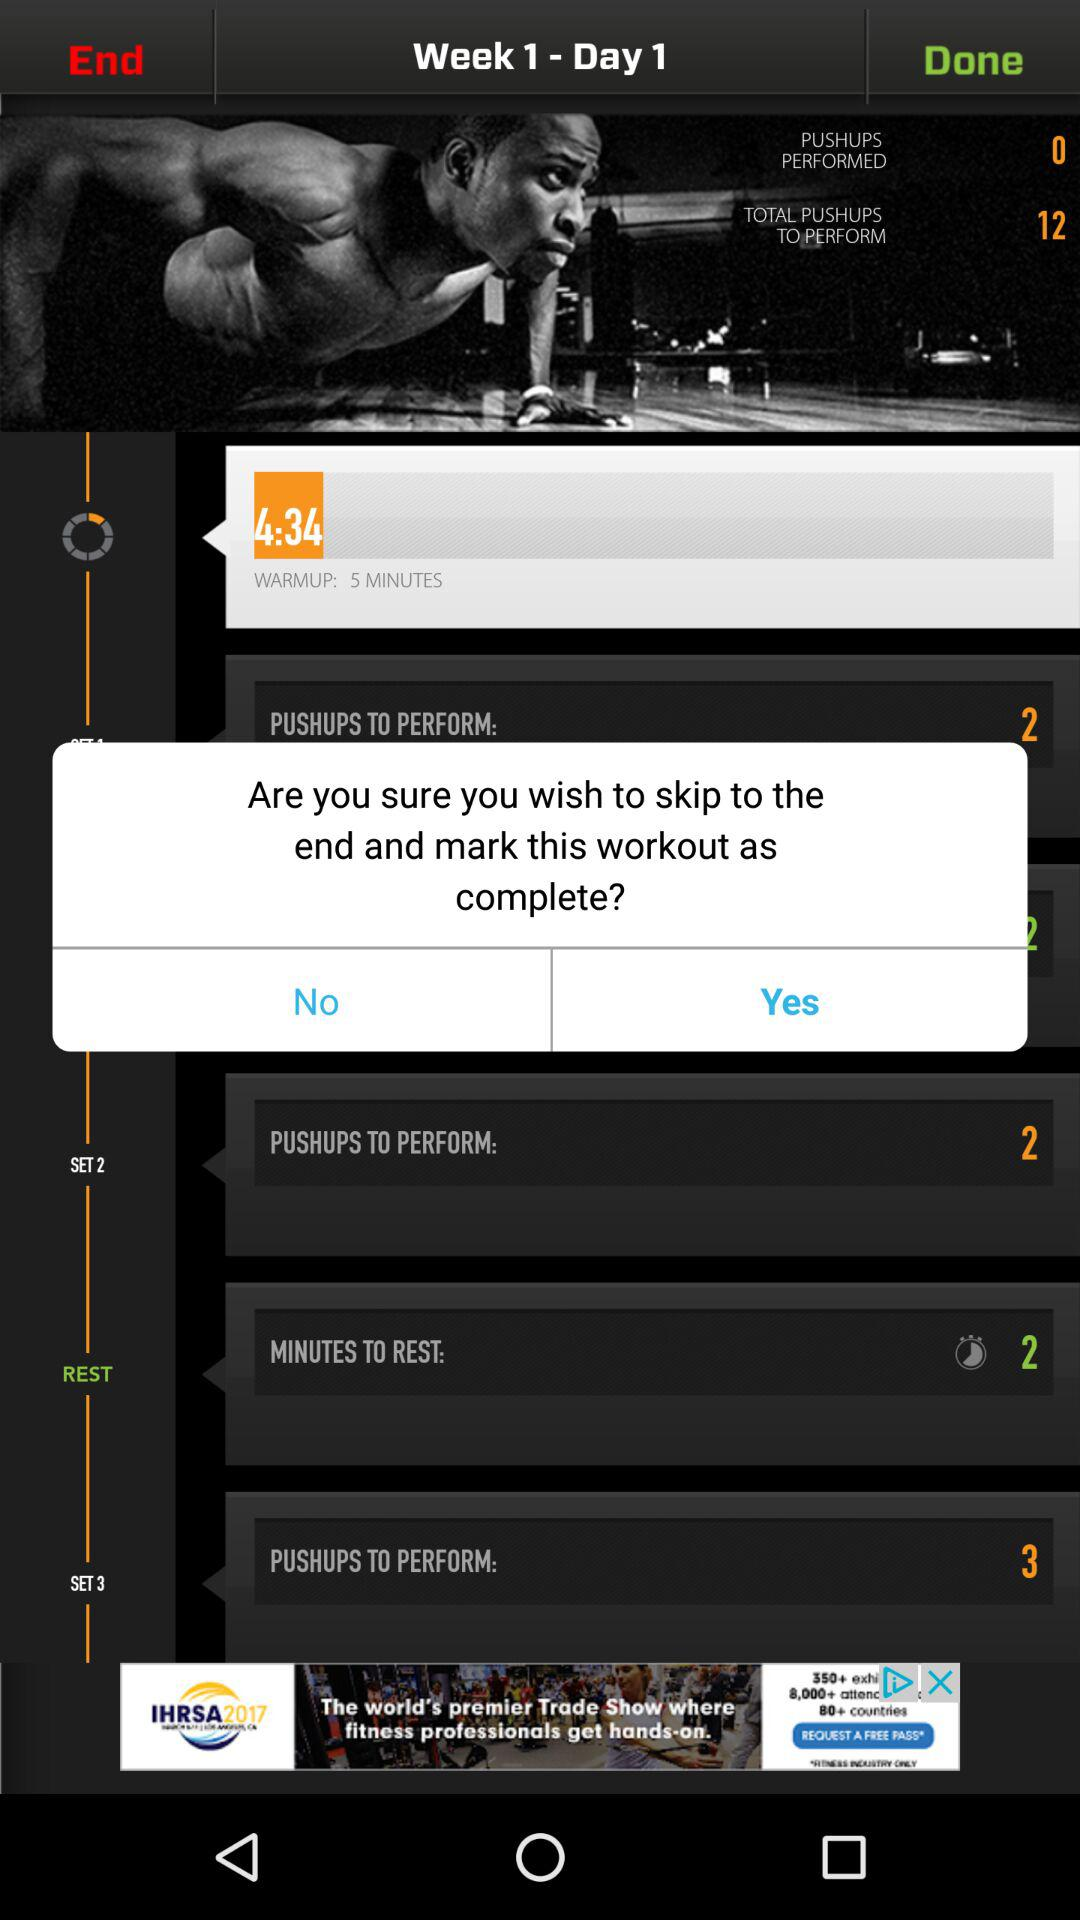What is the time duration of the warmup? The time duration of the warmup is 5 minutes. 